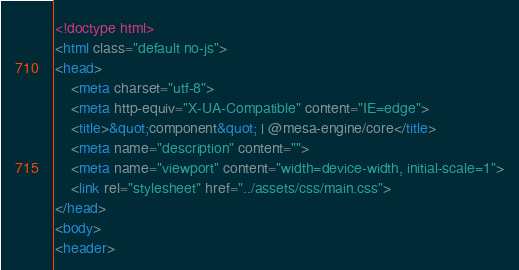Convert code to text. <code><loc_0><loc_0><loc_500><loc_500><_HTML_><!doctype html>
<html class="default no-js">
<head>
	<meta charset="utf-8">
	<meta http-equiv="X-UA-Compatible" content="IE=edge">
	<title>&quot;component&quot; | @mesa-engine/core</title>
	<meta name="description" content="">
	<meta name="viewport" content="width=device-width, initial-scale=1">
	<link rel="stylesheet" href="../assets/css/main.css">
</head>
<body>
<header></code> 